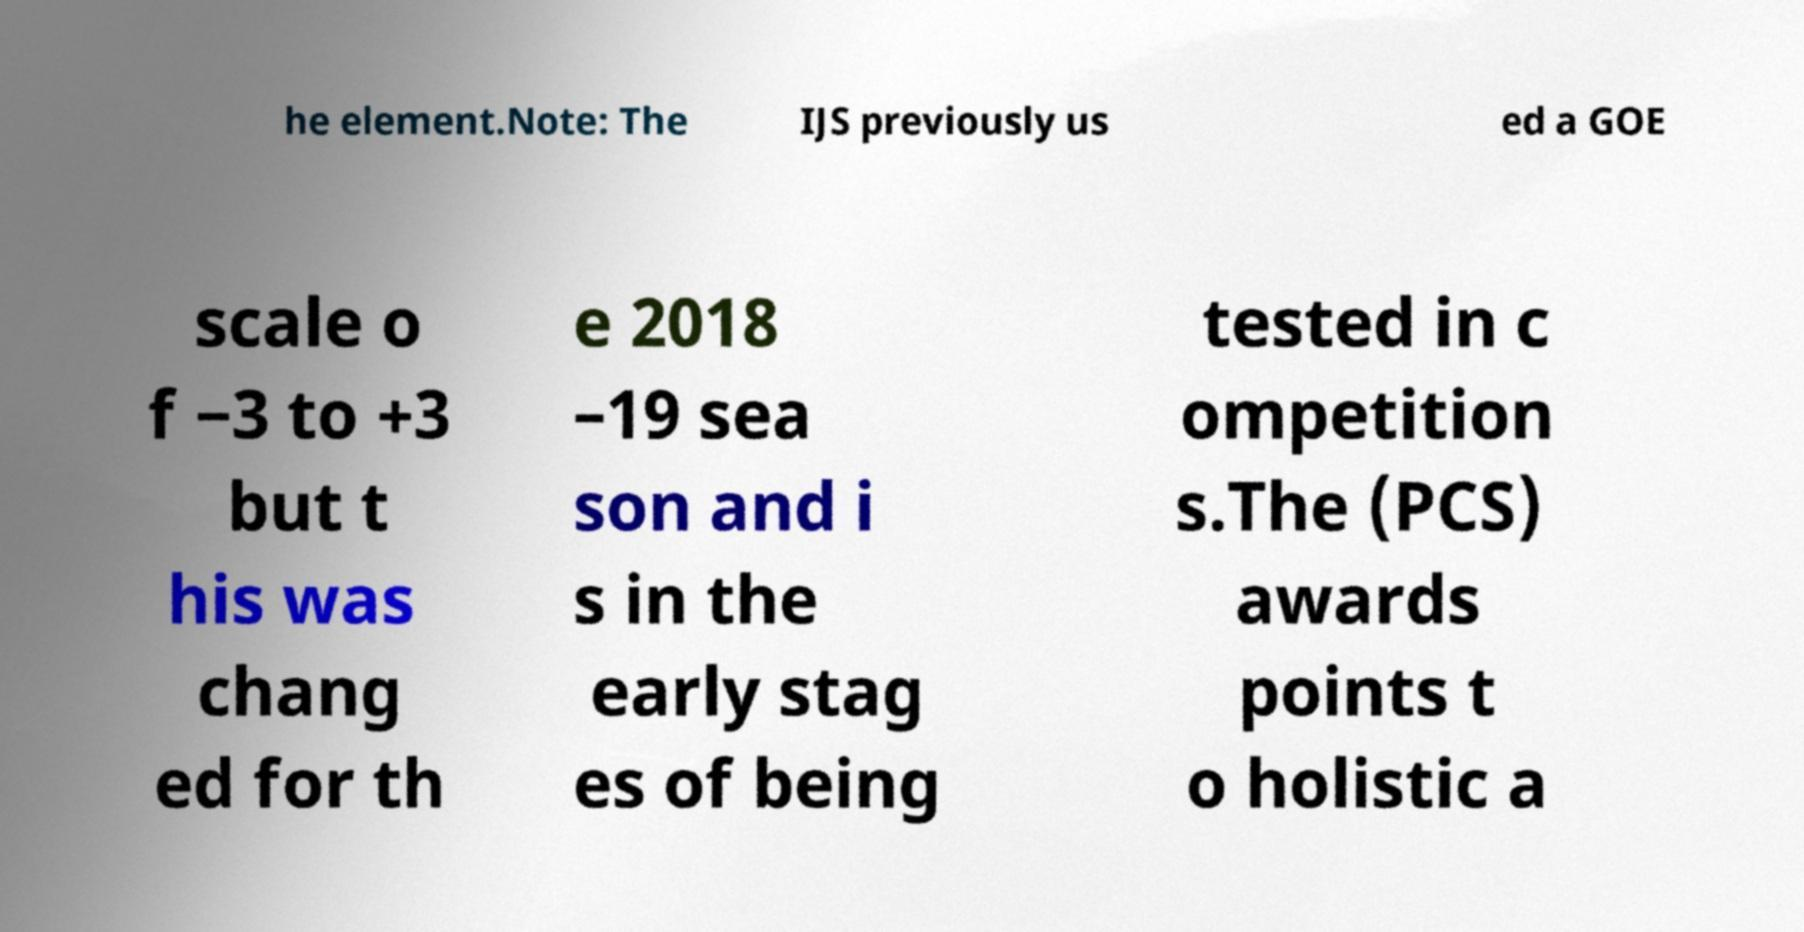Can you read and provide the text displayed in the image?This photo seems to have some interesting text. Can you extract and type it out for me? he element.Note: The IJS previously us ed a GOE scale o f −3 to +3 but t his was chang ed for th e 2018 –19 sea son and i s in the early stag es of being tested in c ompetition s.The (PCS) awards points t o holistic a 